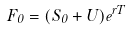<formula> <loc_0><loc_0><loc_500><loc_500>F _ { 0 } = ( S _ { 0 } + U ) e ^ { r T }</formula> 